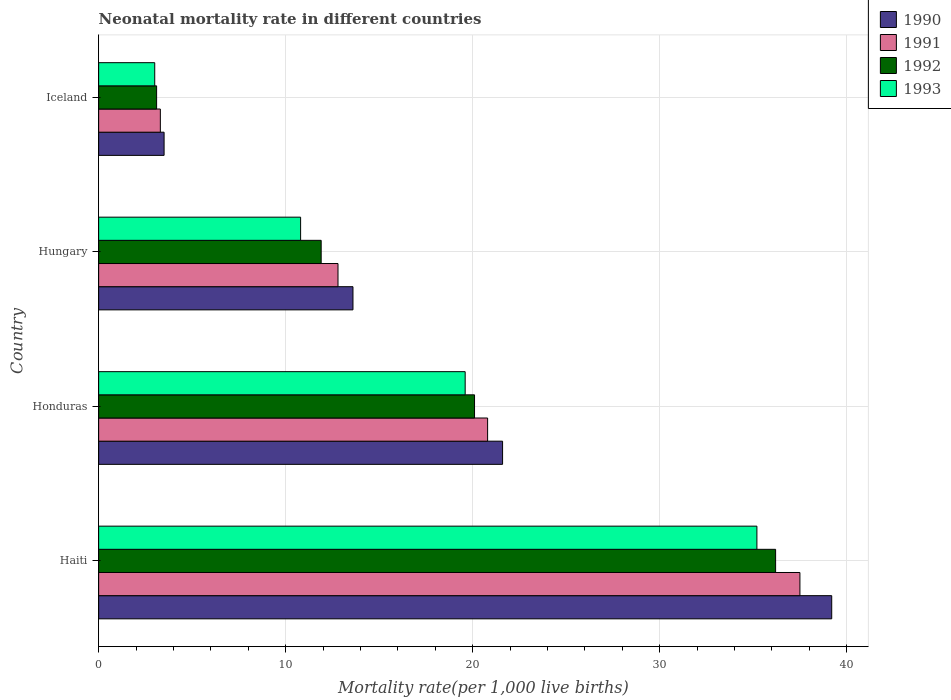Are the number of bars on each tick of the Y-axis equal?
Keep it short and to the point. Yes. What is the label of the 4th group of bars from the top?
Offer a terse response. Haiti. What is the neonatal mortality rate in 1992 in Iceland?
Your response must be concise. 3.1. Across all countries, what is the maximum neonatal mortality rate in 1990?
Offer a very short reply. 39.2. In which country was the neonatal mortality rate in 1990 maximum?
Offer a very short reply. Haiti. What is the total neonatal mortality rate in 1991 in the graph?
Make the answer very short. 74.4. What is the difference between the neonatal mortality rate in 1990 in Honduras and that in Hungary?
Your answer should be compact. 8. What is the difference between the neonatal mortality rate in 1993 in Haiti and the neonatal mortality rate in 1992 in Hungary?
Your answer should be compact. 23.3. What is the average neonatal mortality rate in 1993 per country?
Give a very brief answer. 17.15. What is the difference between the neonatal mortality rate in 1993 and neonatal mortality rate in 1992 in Haiti?
Keep it short and to the point. -1. In how many countries, is the neonatal mortality rate in 1992 greater than 10 ?
Offer a very short reply. 3. What is the ratio of the neonatal mortality rate in 1990 in Honduras to that in Hungary?
Your answer should be compact. 1.59. What is the difference between the highest and the second highest neonatal mortality rate in 1993?
Your answer should be very brief. 15.6. What is the difference between the highest and the lowest neonatal mortality rate in 1993?
Your answer should be very brief. 32.2. In how many countries, is the neonatal mortality rate in 1990 greater than the average neonatal mortality rate in 1990 taken over all countries?
Your answer should be compact. 2. What does the 2nd bar from the bottom in Iceland represents?
Keep it short and to the point. 1991. How many bars are there?
Make the answer very short. 16. What is the difference between two consecutive major ticks on the X-axis?
Ensure brevity in your answer.  10. Are the values on the major ticks of X-axis written in scientific E-notation?
Your response must be concise. No. Does the graph contain any zero values?
Your answer should be compact. No. How many legend labels are there?
Your answer should be compact. 4. How are the legend labels stacked?
Provide a succinct answer. Vertical. What is the title of the graph?
Keep it short and to the point. Neonatal mortality rate in different countries. Does "1982" appear as one of the legend labels in the graph?
Your response must be concise. No. What is the label or title of the X-axis?
Offer a terse response. Mortality rate(per 1,0 live births). What is the label or title of the Y-axis?
Make the answer very short. Country. What is the Mortality rate(per 1,000 live births) of 1990 in Haiti?
Make the answer very short. 39.2. What is the Mortality rate(per 1,000 live births) of 1991 in Haiti?
Your response must be concise. 37.5. What is the Mortality rate(per 1,000 live births) of 1992 in Haiti?
Keep it short and to the point. 36.2. What is the Mortality rate(per 1,000 live births) in 1993 in Haiti?
Offer a terse response. 35.2. What is the Mortality rate(per 1,000 live births) in 1990 in Honduras?
Provide a short and direct response. 21.6. What is the Mortality rate(per 1,000 live births) in 1991 in Honduras?
Give a very brief answer. 20.8. What is the Mortality rate(per 1,000 live births) of 1992 in Honduras?
Your answer should be compact. 20.1. What is the Mortality rate(per 1,000 live births) of 1993 in Honduras?
Offer a very short reply. 19.6. What is the Mortality rate(per 1,000 live births) in 1992 in Hungary?
Your answer should be very brief. 11.9. What is the Mortality rate(per 1,000 live births) of 1993 in Hungary?
Give a very brief answer. 10.8. What is the Mortality rate(per 1,000 live births) in 1991 in Iceland?
Provide a short and direct response. 3.3. What is the Mortality rate(per 1,000 live births) in 1992 in Iceland?
Your answer should be compact. 3.1. Across all countries, what is the maximum Mortality rate(per 1,000 live births) in 1990?
Provide a short and direct response. 39.2. Across all countries, what is the maximum Mortality rate(per 1,000 live births) of 1991?
Keep it short and to the point. 37.5. Across all countries, what is the maximum Mortality rate(per 1,000 live births) of 1992?
Provide a succinct answer. 36.2. Across all countries, what is the maximum Mortality rate(per 1,000 live births) in 1993?
Provide a succinct answer. 35.2. Across all countries, what is the minimum Mortality rate(per 1,000 live births) in 1991?
Offer a terse response. 3.3. Across all countries, what is the minimum Mortality rate(per 1,000 live births) in 1992?
Your answer should be very brief. 3.1. What is the total Mortality rate(per 1,000 live births) of 1990 in the graph?
Your answer should be very brief. 77.9. What is the total Mortality rate(per 1,000 live births) in 1991 in the graph?
Offer a very short reply. 74.4. What is the total Mortality rate(per 1,000 live births) in 1992 in the graph?
Provide a succinct answer. 71.3. What is the total Mortality rate(per 1,000 live births) in 1993 in the graph?
Provide a succinct answer. 68.6. What is the difference between the Mortality rate(per 1,000 live births) in 1990 in Haiti and that in Honduras?
Your answer should be compact. 17.6. What is the difference between the Mortality rate(per 1,000 live births) in 1992 in Haiti and that in Honduras?
Your response must be concise. 16.1. What is the difference between the Mortality rate(per 1,000 live births) of 1993 in Haiti and that in Honduras?
Your answer should be compact. 15.6. What is the difference between the Mortality rate(per 1,000 live births) of 1990 in Haiti and that in Hungary?
Your response must be concise. 25.6. What is the difference between the Mortality rate(per 1,000 live births) in 1991 in Haiti and that in Hungary?
Give a very brief answer. 24.7. What is the difference between the Mortality rate(per 1,000 live births) in 1992 in Haiti and that in Hungary?
Offer a terse response. 24.3. What is the difference between the Mortality rate(per 1,000 live births) of 1993 in Haiti and that in Hungary?
Provide a short and direct response. 24.4. What is the difference between the Mortality rate(per 1,000 live births) of 1990 in Haiti and that in Iceland?
Give a very brief answer. 35.7. What is the difference between the Mortality rate(per 1,000 live births) in 1991 in Haiti and that in Iceland?
Your answer should be compact. 34.2. What is the difference between the Mortality rate(per 1,000 live births) in 1992 in Haiti and that in Iceland?
Ensure brevity in your answer.  33.1. What is the difference between the Mortality rate(per 1,000 live births) of 1993 in Haiti and that in Iceland?
Your answer should be very brief. 32.2. What is the difference between the Mortality rate(per 1,000 live births) in 1991 in Honduras and that in Hungary?
Make the answer very short. 8. What is the difference between the Mortality rate(per 1,000 live births) of 1992 in Honduras and that in Hungary?
Provide a succinct answer. 8.2. What is the difference between the Mortality rate(per 1,000 live births) of 1993 in Honduras and that in Hungary?
Offer a terse response. 8.8. What is the difference between the Mortality rate(per 1,000 live births) of 1993 in Honduras and that in Iceland?
Your answer should be compact. 16.6. What is the difference between the Mortality rate(per 1,000 live births) in 1990 in Hungary and that in Iceland?
Your response must be concise. 10.1. What is the difference between the Mortality rate(per 1,000 live births) of 1992 in Hungary and that in Iceland?
Provide a short and direct response. 8.8. What is the difference between the Mortality rate(per 1,000 live births) of 1993 in Hungary and that in Iceland?
Offer a very short reply. 7.8. What is the difference between the Mortality rate(per 1,000 live births) of 1990 in Haiti and the Mortality rate(per 1,000 live births) of 1992 in Honduras?
Provide a short and direct response. 19.1. What is the difference between the Mortality rate(per 1,000 live births) of 1990 in Haiti and the Mortality rate(per 1,000 live births) of 1993 in Honduras?
Your response must be concise. 19.6. What is the difference between the Mortality rate(per 1,000 live births) of 1991 in Haiti and the Mortality rate(per 1,000 live births) of 1993 in Honduras?
Your answer should be very brief. 17.9. What is the difference between the Mortality rate(per 1,000 live births) of 1990 in Haiti and the Mortality rate(per 1,000 live births) of 1991 in Hungary?
Your answer should be compact. 26.4. What is the difference between the Mortality rate(per 1,000 live births) of 1990 in Haiti and the Mortality rate(per 1,000 live births) of 1992 in Hungary?
Offer a terse response. 27.3. What is the difference between the Mortality rate(per 1,000 live births) in 1990 in Haiti and the Mortality rate(per 1,000 live births) in 1993 in Hungary?
Make the answer very short. 28.4. What is the difference between the Mortality rate(per 1,000 live births) of 1991 in Haiti and the Mortality rate(per 1,000 live births) of 1992 in Hungary?
Provide a succinct answer. 25.6. What is the difference between the Mortality rate(per 1,000 live births) of 1991 in Haiti and the Mortality rate(per 1,000 live births) of 1993 in Hungary?
Provide a short and direct response. 26.7. What is the difference between the Mortality rate(per 1,000 live births) of 1992 in Haiti and the Mortality rate(per 1,000 live births) of 1993 in Hungary?
Ensure brevity in your answer.  25.4. What is the difference between the Mortality rate(per 1,000 live births) in 1990 in Haiti and the Mortality rate(per 1,000 live births) in 1991 in Iceland?
Keep it short and to the point. 35.9. What is the difference between the Mortality rate(per 1,000 live births) of 1990 in Haiti and the Mortality rate(per 1,000 live births) of 1992 in Iceland?
Keep it short and to the point. 36.1. What is the difference between the Mortality rate(per 1,000 live births) in 1990 in Haiti and the Mortality rate(per 1,000 live births) in 1993 in Iceland?
Provide a succinct answer. 36.2. What is the difference between the Mortality rate(per 1,000 live births) in 1991 in Haiti and the Mortality rate(per 1,000 live births) in 1992 in Iceland?
Provide a succinct answer. 34.4. What is the difference between the Mortality rate(per 1,000 live births) in 1991 in Haiti and the Mortality rate(per 1,000 live births) in 1993 in Iceland?
Offer a terse response. 34.5. What is the difference between the Mortality rate(per 1,000 live births) in 1992 in Haiti and the Mortality rate(per 1,000 live births) in 1993 in Iceland?
Give a very brief answer. 33.2. What is the difference between the Mortality rate(per 1,000 live births) in 1990 in Honduras and the Mortality rate(per 1,000 live births) in 1991 in Hungary?
Your answer should be compact. 8.8. What is the difference between the Mortality rate(per 1,000 live births) in 1992 in Honduras and the Mortality rate(per 1,000 live births) in 1993 in Hungary?
Give a very brief answer. 9.3. What is the difference between the Mortality rate(per 1,000 live births) of 1990 in Honduras and the Mortality rate(per 1,000 live births) of 1991 in Iceland?
Make the answer very short. 18.3. What is the difference between the Mortality rate(per 1,000 live births) of 1990 in Honduras and the Mortality rate(per 1,000 live births) of 1992 in Iceland?
Give a very brief answer. 18.5. What is the difference between the Mortality rate(per 1,000 live births) in 1990 in Honduras and the Mortality rate(per 1,000 live births) in 1993 in Iceland?
Your answer should be very brief. 18.6. What is the difference between the Mortality rate(per 1,000 live births) of 1992 in Honduras and the Mortality rate(per 1,000 live births) of 1993 in Iceland?
Provide a succinct answer. 17.1. What is the difference between the Mortality rate(per 1,000 live births) of 1990 in Hungary and the Mortality rate(per 1,000 live births) of 1991 in Iceland?
Your response must be concise. 10.3. What is the difference between the Mortality rate(per 1,000 live births) in 1990 in Hungary and the Mortality rate(per 1,000 live births) in 1993 in Iceland?
Offer a terse response. 10.6. What is the difference between the Mortality rate(per 1,000 live births) of 1991 in Hungary and the Mortality rate(per 1,000 live births) of 1992 in Iceland?
Ensure brevity in your answer.  9.7. What is the difference between the Mortality rate(per 1,000 live births) of 1991 in Hungary and the Mortality rate(per 1,000 live births) of 1993 in Iceland?
Make the answer very short. 9.8. What is the average Mortality rate(per 1,000 live births) in 1990 per country?
Your answer should be compact. 19.48. What is the average Mortality rate(per 1,000 live births) in 1992 per country?
Provide a short and direct response. 17.82. What is the average Mortality rate(per 1,000 live births) in 1993 per country?
Make the answer very short. 17.15. What is the difference between the Mortality rate(per 1,000 live births) of 1990 and Mortality rate(per 1,000 live births) of 1991 in Haiti?
Offer a very short reply. 1.7. What is the difference between the Mortality rate(per 1,000 live births) of 1990 and Mortality rate(per 1,000 live births) of 1992 in Haiti?
Your answer should be compact. 3. What is the difference between the Mortality rate(per 1,000 live births) in 1990 and Mortality rate(per 1,000 live births) in 1993 in Haiti?
Make the answer very short. 4. What is the difference between the Mortality rate(per 1,000 live births) of 1991 and Mortality rate(per 1,000 live births) of 1992 in Haiti?
Offer a very short reply. 1.3. What is the difference between the Mortality rate(per 1,000 live births) of 1991 and Mortality rate(per 1,000 live births) of 1993 in Haiti?
Your response must be concise. 2.3. What is the difference between the Mortality rate(per 1,000 live births) in 1990 and Mortality rate(per 1,000 live births) in 1992 in Honduras?
Your answer should be very brief. 1.5. What is the difference between the Mortality rate(per 1,000 live births) of 1991 and Mortality rate(per 1,000 live births) of 1993 in Honduras?
Your answer should be very brief. 1.2. What is the difference between the Mortality rate(per 1,000 live births) of 1990 and Mortality rate(per 1,000 live births) of 1993 in Hungary?
Ensure brevity in your answer.  2.8. What is the difference between the Mortality rate(per 1,000 live births) in 1991 and Mortality rate(per 1,000 live births) in 1992 in Hungary?
Provide a short and direct response. 0.9. What is the difference between the Mortality rate(per 1,000 live births) of 1991 and Mortality rate(per 1,000 live births) of 1993 in Hungary?
Provide a short and direct response. 2. What is the difference between the Mortality rate(per 1,000 live births) of 1990 and Mortality rate(per 1,000 live births) of 1991 in Iceland?
Provide a short and direct response. 0.2. What is the difference between the Mortality rate(per 1,000 live births) in 1990 and Mortality rate(per 1,000 live births) in 1992 in Iceland?
Offer a terse response. 0.4. What is the difference between the Mortality rate(per 1,000 live births) in 1990 and Mortality rate(per 1,000 live births) in 1993 in Iceland?
Ensure brevity in your answer.  0.5. What is the difference between the Mortality rate(per 1,000 live births) of 1991 and Mortality rate(per 1,000 live births) of 1992 in Iceland?
Make the answer very short. 0.2. What is the difference between the Mortality rate(per 1,000 live births) of 1992 and Mortality rate(per 1,000 live births) of 1993 in Iceland?
Ensure brevity in your answer.  0.1. What is the ratio of the Mortality rate(per 1,000 live births) of 1990 in Haiti to that in Honduras?
Keep it short and to the point. 1.81. What is the ratio of the Mortality rate(per 1,000 live births) in 1991 in Haiti to that in Honduras?
Make the answer very short. 1.8. What is the ratio of the Mortality rate(per 1,000 live births) in 1992 in Haiti to that in Honduras?
Offer a very short reply. 1.8. What is the ratio of the Mortality rate(per 1,000 live births) of 1993 in Haiti to that in Honduras?
Provide a short and direct response. 1.8. What is the ratio of the Mortality rate(per 1,000 live births) in 1990 in Haiti to that in Hungary?
Your answer should be very brief. 2.88. What is the ratio of the Mortality rate(per 1,000 live births) of 1991 in Haiti to that in Hungary?
Your response must be concise. 2.93. What is the ratio of the Mortality rate(per 1,000 live births) in 1992 in Haiti to that in Hungary?
Your answer should be compact. 3.04. What is the ratio of the Mortality rate(per 1,000 live births) of 1993 in Haiti to that in Hungary?
Your response must be concise. 3.26. What is the ratio of the Mortality rate(per 1,000 live births) in 1991 in Haiti to that in Iceland?
Your answer should be compact. 11.36. What is the ratio of the Mortality rate(per 1,000 live births) of 1992 in Haiti to that in Iceland?
Ensure brevity in your answer.  11.68. What is the ratio of the Mortality rate(per 1,000 live births) in 1993 in Haiti to that in Iceland?
Give a very brief answer. 11.73. What is the ratio of the Mortality rate(per 1,000 live births) in 1990 in Honduras to that in Hungary?
Make the answer very short. 1.59. What is the ratio of the Mortality rate(per 1,000 live births) of 1991 in Honduras to that in Hungary?
Ensure brevity in your answer.  1.62. What is the ratio of the Mortality rate(per 1,000 live births) in 1992 in Honduras to that in Hungary?
Give a very brief answer. 1.69. What is the ratio of the Mortality rate(per 1,000 live births) of 1993 in Honduras to that in Hungary?
Your answer should be very brief. 1.81. What is the ratio of the Mortality rate(per 1,000 live births) of 1990 in Honduras to that in Iceland?
Your answer should be compact. 6.17. What is the ratio of the Mortality rate(per 1,000 live births) in 1991 in Honduras to that in Iceland?
Offer a terse response. 6.3. What is the ratio of the Mortality rate(per 1,000 live births) of 1992 in Honduras to that in Iceland?
Ensure brevity in your answer.  6.48. What is the ratio of the Mortality rate(per 1,000 live births) of 1993 in Honduras to that in Iceland?
Give a very brief answer. 6.53. What is the ratio of the Mortality rate(per 1,000 live births) of 1990 in Hungary to that in Iceland?
Your answer should be compact. 3.89. What is the ratio of the Mortality rate(per 1,000 live births) of 1991 in Hungary to that in Iceland?
Make the answer very short. 3.88. What is the ratio of the Mortality rate(per 1,000 live births) in 1992 in Hungary to that in Iceland?
Make the answer very short. 3.84. What is the difference between the highest and the second highest Mortality rate(per 1,000 live births) of 1990?
Give a very brief answer. 17.6. What is the difference between the highest and the second highest Mortality rate(per 1,000 live births) in 1991?
Your answer should be compact. 16.7. What is the difference between the highest and the second highest Mortality rate(per 1,000 live births) of 1992?
Offer a very short reply. 16.1. What is the difference between the highest and the second highest Mortality rate(per 1,000 live births) in 1993?
Keep it short and to the point. 15.6. What is the difference between the highest and the lowest Mortality rate(per 1,000 live births) of 1990?
Make the answer very short. 35.7. What is the difference between the highest and the lowest Mortality rate(per 1,000 live births) of 1991?
Offer a very short reply. 34.2. What is the difference between the highest and the lowest Mortality rate(per 1,000 live births) of 1992?
Offer a very short reply. 33.1. What is the difference between the highest and the lowest Mortality rate(per 1,000 live births) in 1993?
Provide a succinct answer. 32.2. 